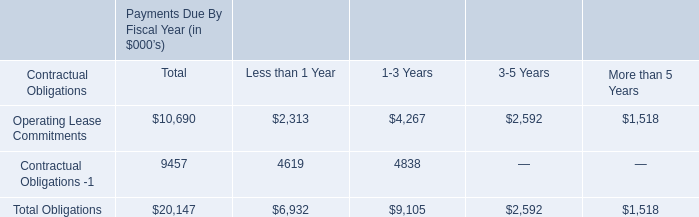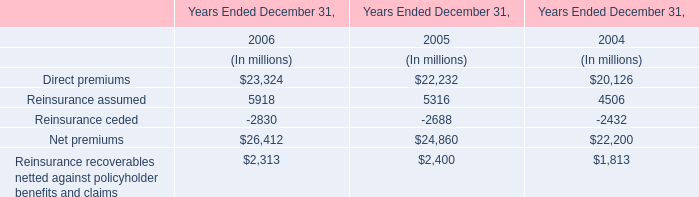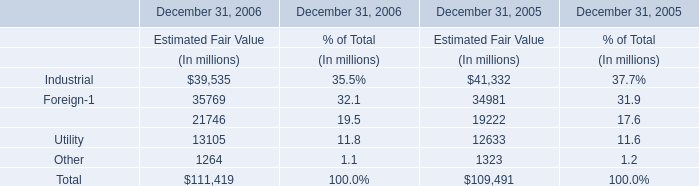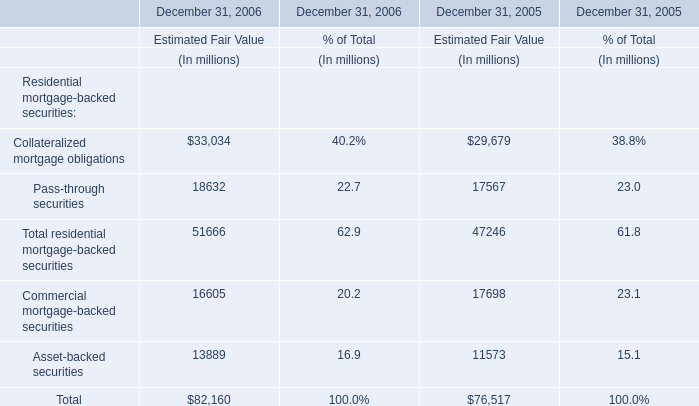What's the 30% of total elements in 2005? (in million) 
Computations: (109491 * 0.3)
Answer: 32847.3. 